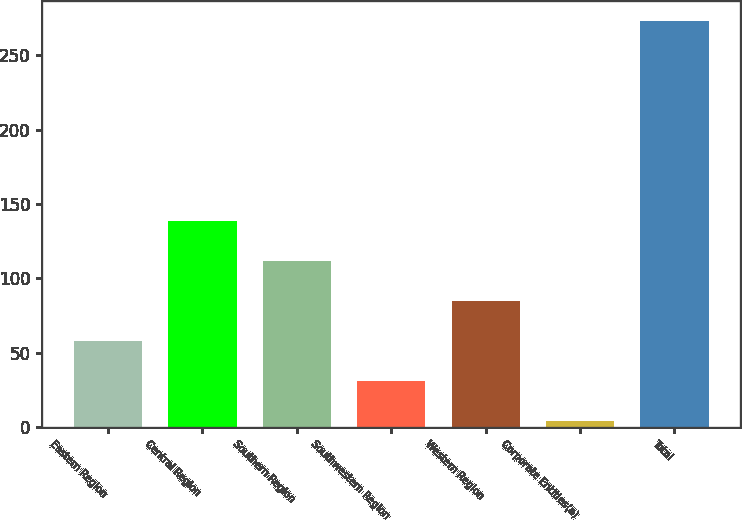<chart> <loc_0><loc_0><loc_500><loc_500><bar_chart><fcel>Eastern Region<fcel>Central Region<fcel>Southern Region<fcel>Southwestern Region<fcel>Western Region<fcel>Corporate Entities(a)<fcel>Total<nl><fcel>58.06<fcel>138.7<fcel>111.82<fcel>31.18<fcel>84.94<fcel>4.3<fcel>273.1<nl></chart> 